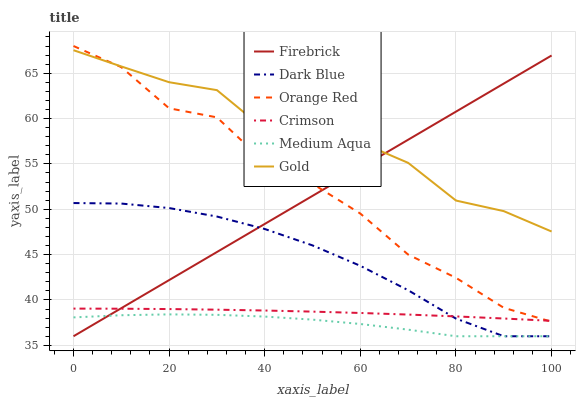Does Medium Aqua have the minimum area under the curve?
Answer yes or no. Yes. Does Gold have the maximum area under the curve?
Answer yes or no. Yes. Does Firebrick have the minimum area under the curve?
Answer yes or no. No. Does Firebrick have the maximum area under the curve?
Answer yes or no. No. Is Firebrick the smoothest?
Answer yes or no. Yes. Is Orange Red the roughest?
Answer yes or no. Yes. Is Dark Blue the smoothest?
Answer yes or no. No. Is Dark Blue the roughest?
Answer yes or no. No. Does Crimson have the lowest value?
Answer yes or no. No. Does Orange Red have the highest value?
Answer yes or no. Yes. Does Firebrick have the highest value?
Answer yes or no. No. Is Medium Aqua less than Crimson?
Answer yes or no. Yes. Is Gold greater than Medium Aqua?
Answer yes or no. Yes. Does Dark Blue intersect Crimson?
Answer yes or no. Yes. Is Dark Blue less than Crimson?
Answer yes or no. No. Is Dark Blue greater than Crimson?
Answer yes or no. No. Does Medium Aqua intersect Crimson?
Answer yes or no. No. 